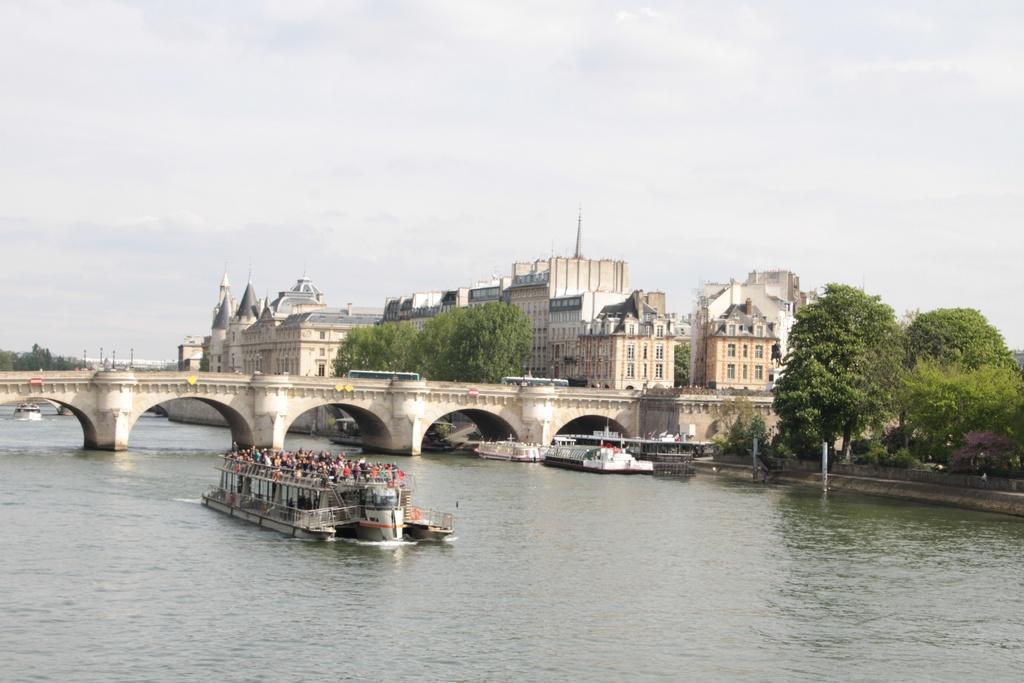Can you describe this image briefly? This image is taken outdoors. At the top of the image there is the sky with clouds. At the bottom of the image there is a river with water. In the background there are many buildings with walls, windows, roofs and doors. There are a few trees. In the middle of the image there is a bridge with pillars and walls. Two buses are moving on the bridge. There are a few boats on the river. There are a few people in the boat. On the right side of the image there are a few trees and plants on the ground. 